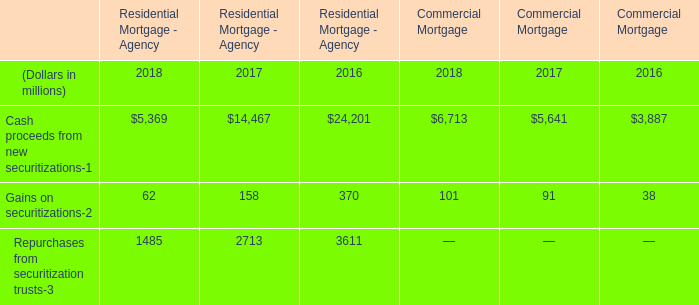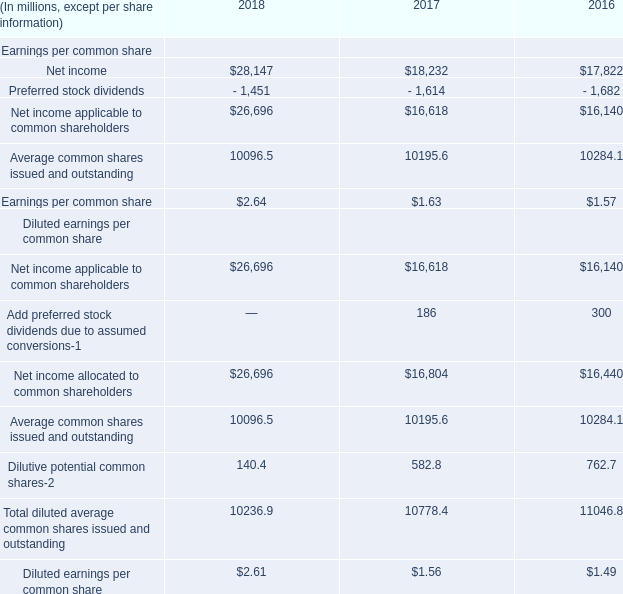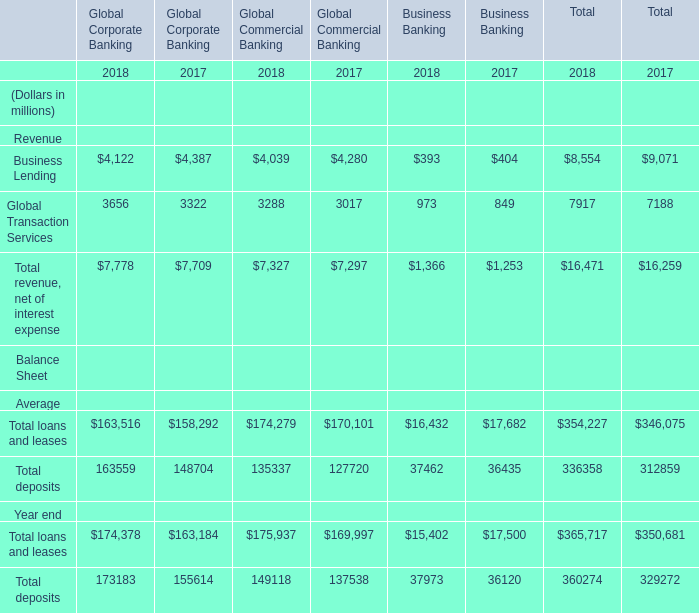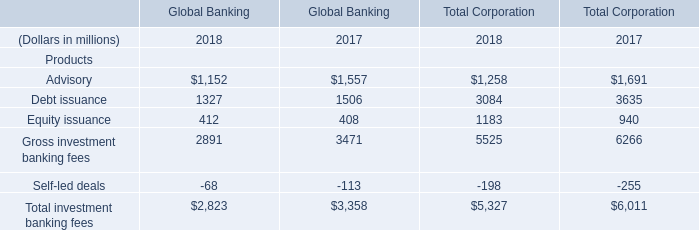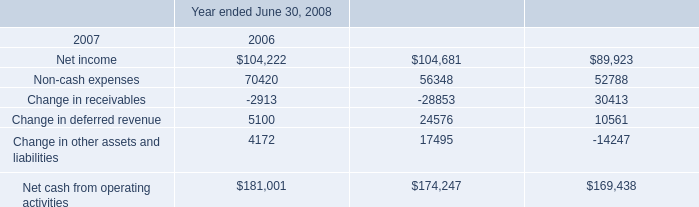What will Equity issuance of Global Banking reach in 2019 if it continues to grow at its current rate? (in dollars in millions) 
Computations: (412 * (1 + ((412 - 408) / 408)))
Answer: 416.03922. 